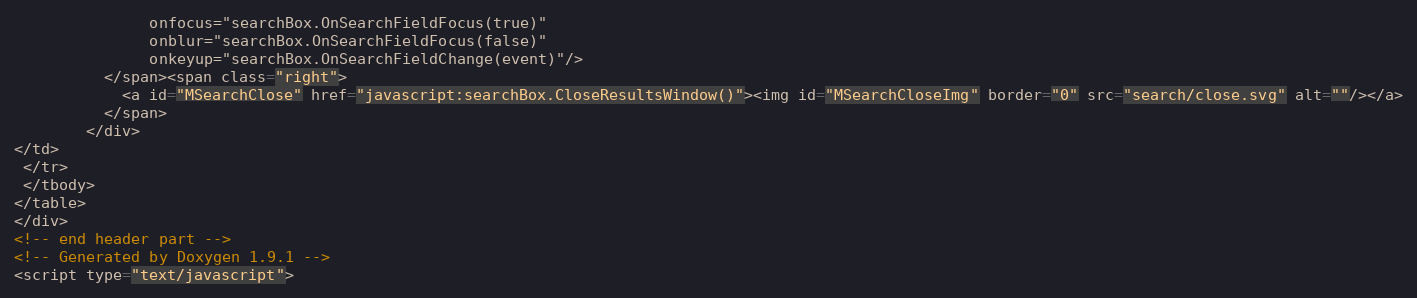<code> <loc_0><loc_0><loc_500><loc_500><_HTML_>               onfocus="searchBox.OnSearchFieldFocus(true)" 
               onblur="searchBox.OnSearchFieldFocus(false)" 
               onkeyup="searchBox.OnSearchFieldChange(event)"/>
          </span><span class="right">
            <a id="MSearchClose" href="javascript:searchBox.CloseResultsWindow()"><img id="MSearchCloseImg" border="0" src="search/close.svg" alt=""/></a>
          </span>
        </div>
</td>
 </tr>
 </tbody>
</table>
</div>
<!-- end header part -->
<!-- Generated by Doxygen 1.9.1 -->
<script type="text/javascript"></code> 